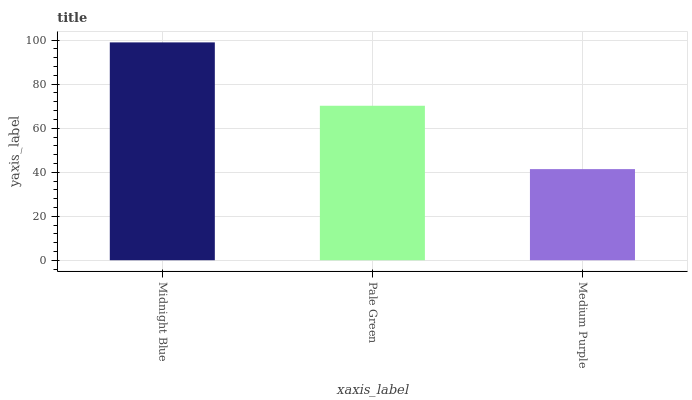Is Medium Purple the minimum?
Answer yes or no. Yes. Is Midnight Blue the maximum?
Answer yes or no. Yes. Is Pale Green the minimum?
Answer yes or no. No. Is Pale Green the maximum?
Answer yes or no. No. Is Midnight Blue greater than Pale Green?
Answer yes or no. Yes. Is Pale Green less than Midnight Blue?
Answer yes or no. Yes. Is Pale Green greater than Midnight Blue?
Answer yes or no. No. Is Midnight Blue less than Pale Green?
Answer yes or no. No. Is Pale Green the high median?
Answer yes or no. Yes. Is Pale Green the low median?
Answer yes or no. Yes. Is Midnight Blue the high median?
Answer yes or no. No. Is Midnight Blue the low median?
Answer yes or no. No. 